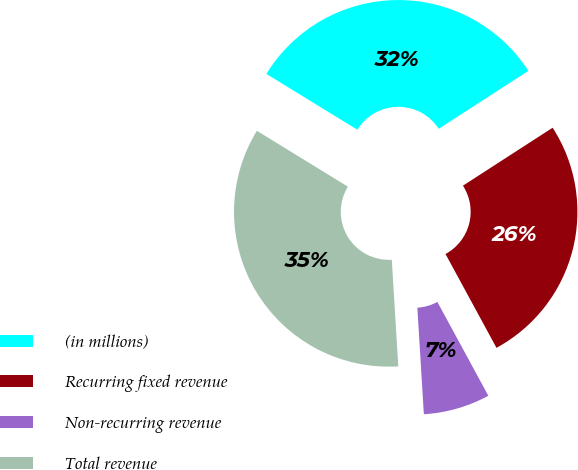<chart> <loc_0><loc_0><loc_500><loc_500><pie_chart><fcel>(in millions)<fcel>Recurring fixed revenue<fcel>Non-recurring revenue<fcel>Total revenue<nl><fcel>32.11%<fcel>26.21%<fcel>6.95%<fcel>34.73%<nl></chart> 